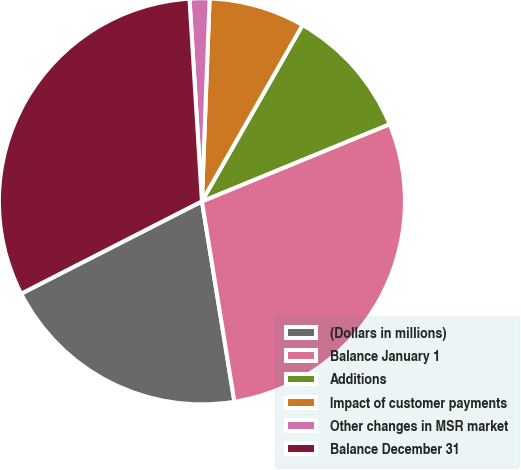Convert chart to OTSL. <chart><loc_0><loc_0><loc_500><loc_500><pie_chart><fcel>(Dollars in millions)<fcel>Balance January 1<fcel>Additions<fcel>Impact of customer payments<fcel>Other changes in MSR market<fcel>Balance December 31<nl><fcel>20.04%<fcel>28.65%<fcel>10.54%<fcel>7.65%<fcel>1.58%<fcel>31.54%<nl></chart> 